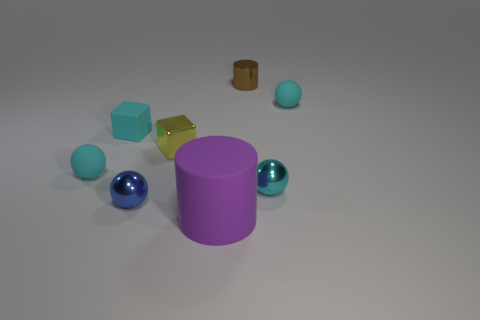Subtract all cyan spheres. How many were subtracted if there are1cyan spheres left? 2 Subtract all tiny cyan metal balls. How many balls are left? 3 Add 1 red cylinders. How many objects exist? 9 Subtract all blue balls. How many balls are left? 3 Subtract all purple cylinders. How many cyan balls are left? 3 Subtract 1 cubes. How many cubes are left? 1 Subtract all cylinders. How many objects are left? 6 Add 1 brown objects. How many brown objects are left? 2 Add 4 large blue rubber things. How many large blue rubber things exist? 4 Subtract 0 yellow cylinders. How many objects are left? 8 